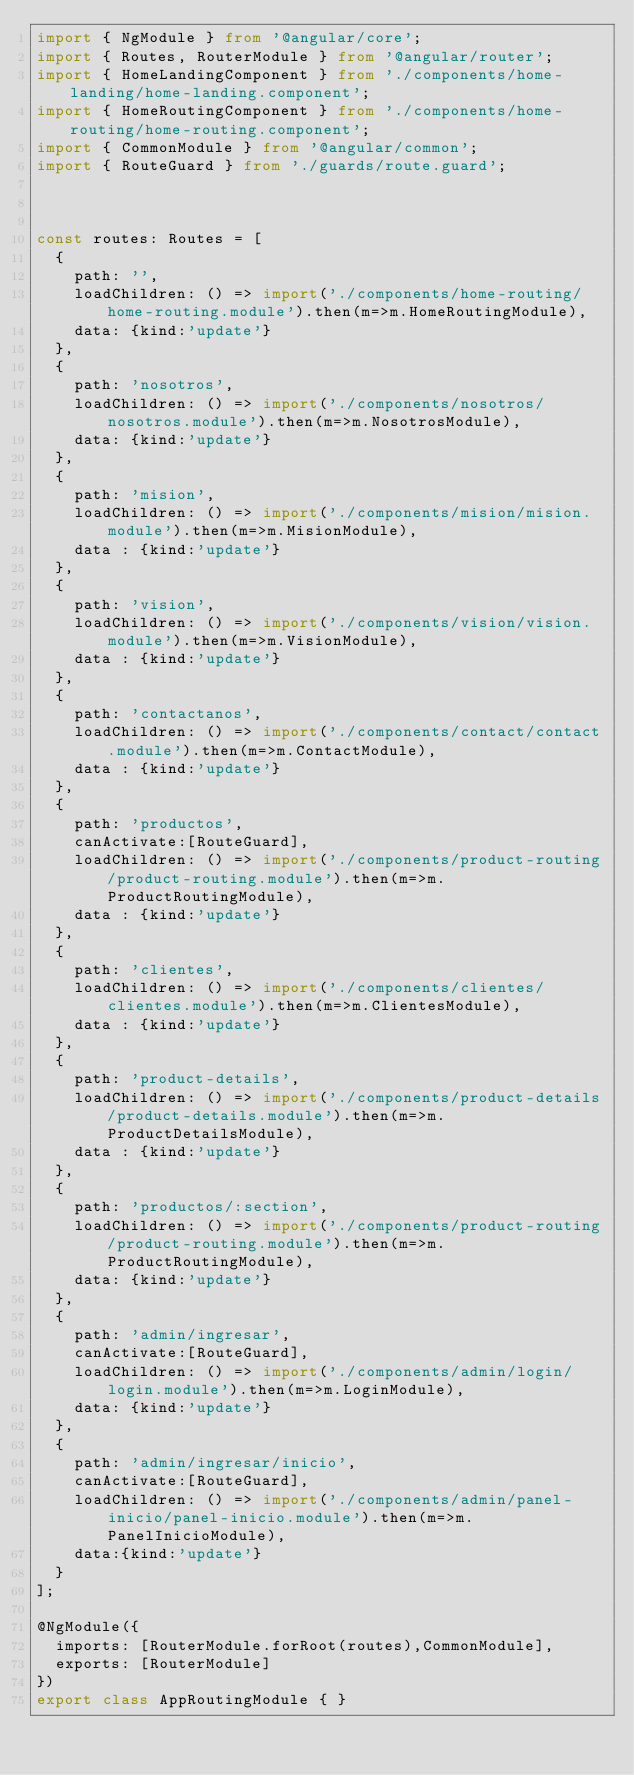Convert code to text. <code><loc_0><loc_0><loc_500><loc_500><_TypeScript_>import { NgModule } from '@angular/core';
import { Routes, RouterModule } from '@angular/router';
import { HomeLandingComponent } from './components/home-landing/home-landing.component';
import { HomeRoutingComponent } from './components/home-routing/home-routing.component';
import { CommonModule } from '@angular/common';
import { RouteGuard } from './guards/route.guard';



const routes: Routes = [
  {
    path: '',
    loadChildren: () => import('./components/home-routing/home-routing.module').then(m=>m.HomeRoutingModule),
    data: {kind:'update'}
  },
  {
    path: 'nosotros',
    loadChildren: () => import('./components/nosotros/nosotros.module').then(m=>m.NosotrosModule),
    data: {kind:'update'}
  },
  {
    path: 'mision',
    loadChildren: () => import('./components/mision/mision.module').then(m=>m.MisionModule),
    data : {kind:'update'}
  },
  {
    path: 'vision',
    loadChildren: () => import('./components/vision/vision.module').then(m=>m.VisionModule),
    data : {kind:'update'}
  },
  {
    path: 'contactanos',
    loadChildren: () => import('./components/contact/contact.module').then(m=>m.ContactModule),
    data : {kind:'update'}
  },
  {
    path: 'productos',
    canActivate:[RouteGuard],
    loadChildren: () => import('./components/product-routing/product-routing.module').then(m=>m.ProductRoutingModule),
    data : {kind:'update'}
  },
  {
    path: 'clientes',
    loadChildren: () => import('./components/clientes/clientes.module').then(m=>m.ClientesModule),
    data : {kind:'update'}
  },
  {
    path: 'product-details',
    loadChildren: () => import('./components/product-details/product-details.module').then(m=>m.ProductDetailsModule),
    data : {kind:'update'}
  },
  {
    path: 'productos/:section',
    loadChildren: () => import('./components/product-routing/product-routing.module').then(m=>m.ProductRoutingModule),
    data: {kind:'update'}
  },
  {
    path: 'admin/ingresar',
    canActivate:[RouteGuard],
    loadChildren: () => import('./components/admin/login/login.module').then(m=>m.LoginModule),
    data: {kind:'update'}
  },
  {
    path: 'admin/ingresar/inicio',
    canActivate:[RouteGuard],
    loadChildren: () => import('./components/admin/panel-inicio/panel-inicio.module').then(m=>m.PanelInicioModule),
    data:{kind:'update'}
  }
];

@NgModule({
  imports: [RouterModule.forRoot(routes),CommonModule],
  exports: [RouterModule]
})
export class AppRoutingModule { }
</code> 